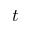<formula> <loc_0><loc_0><loc_500><loc_500>t</formula> 